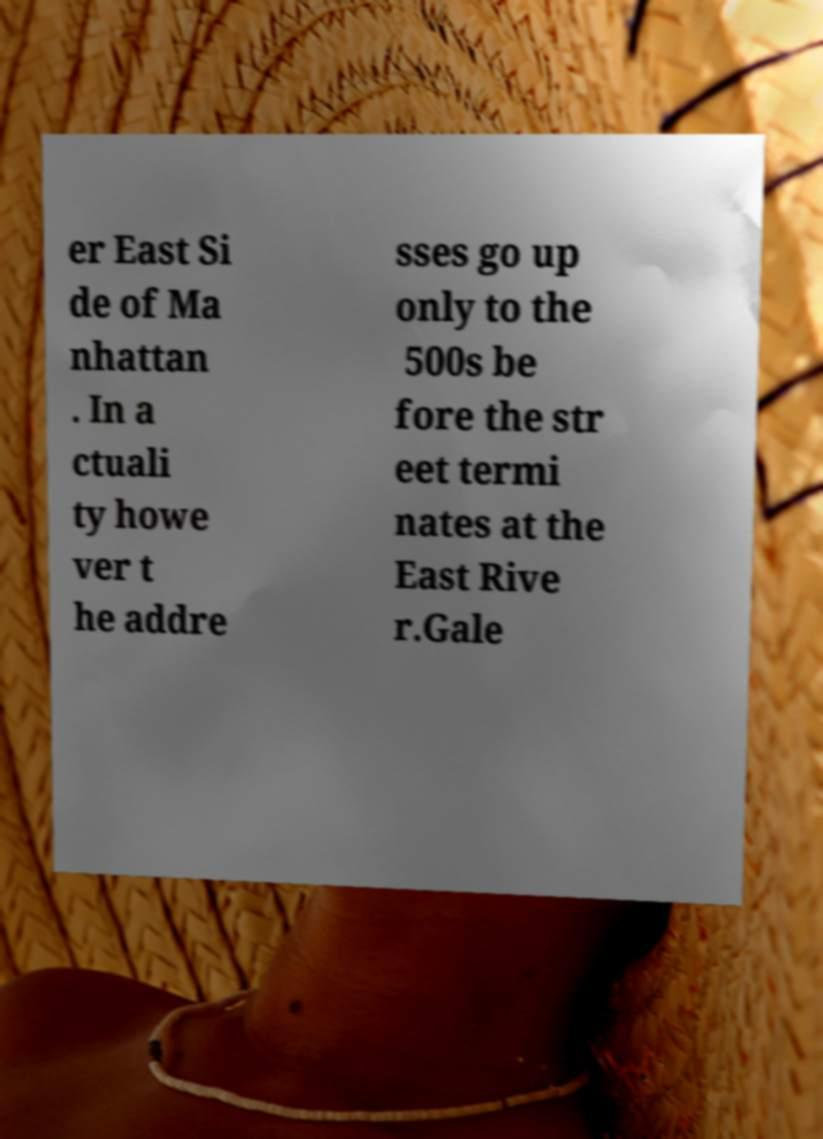Please identify and transcribe the text found in this image. er East Si de of Ma nhattan . In a ctuali ty howe ver t he addre sses go up only to the 500s be fore the str eet termi nates at the East Rive r.Gale 